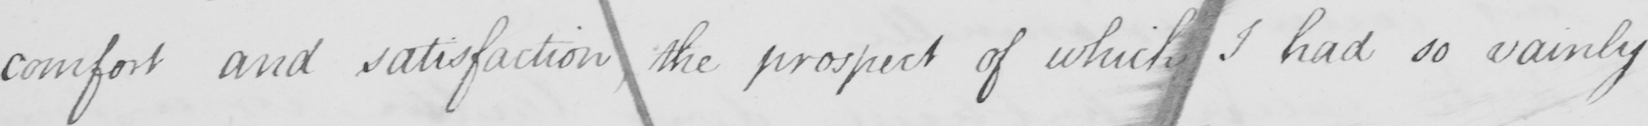What is written in this line of handwriting? comfort and satisfaction, the prospect of which I had so vainly 